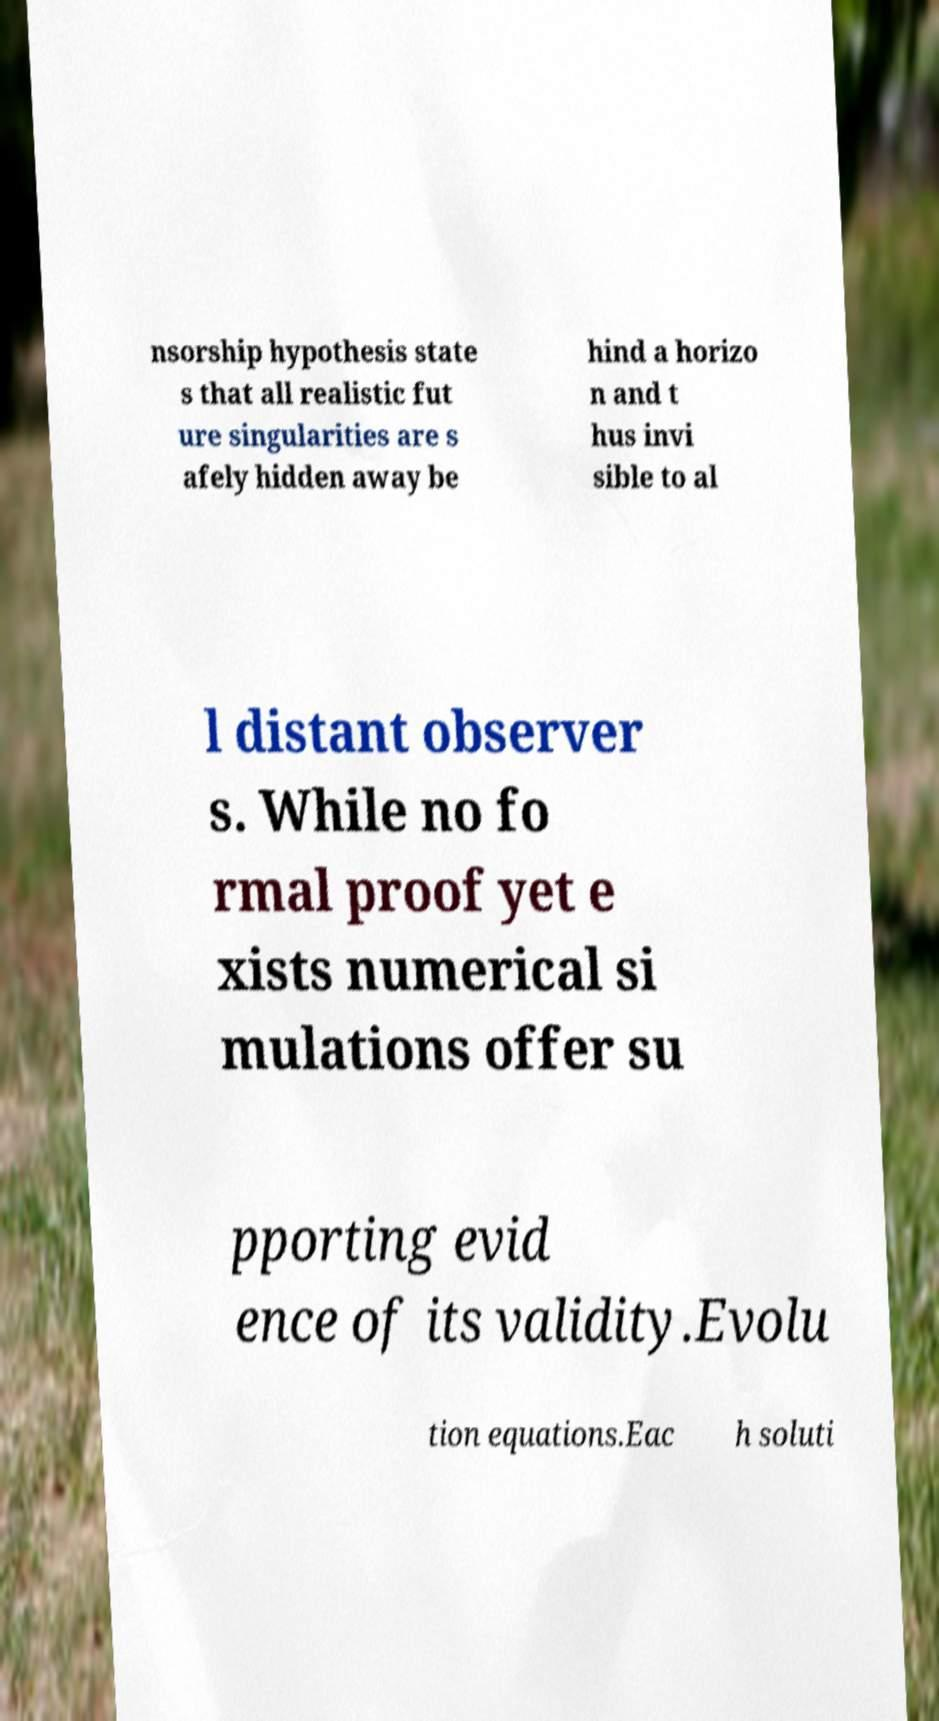For documentation purposes, I need the text within this image transcribed. Could you provide that? nsorship hypothesis state s that all realistic fut ure singularities are s afely hidden away be hind a horizo n and t hus invi sible to al l distant observer s. While no fo rmal proof yet e xists numerical si mulations offer su pporting evid ence of its validity.Evolu tion equations.Eac h soluti 